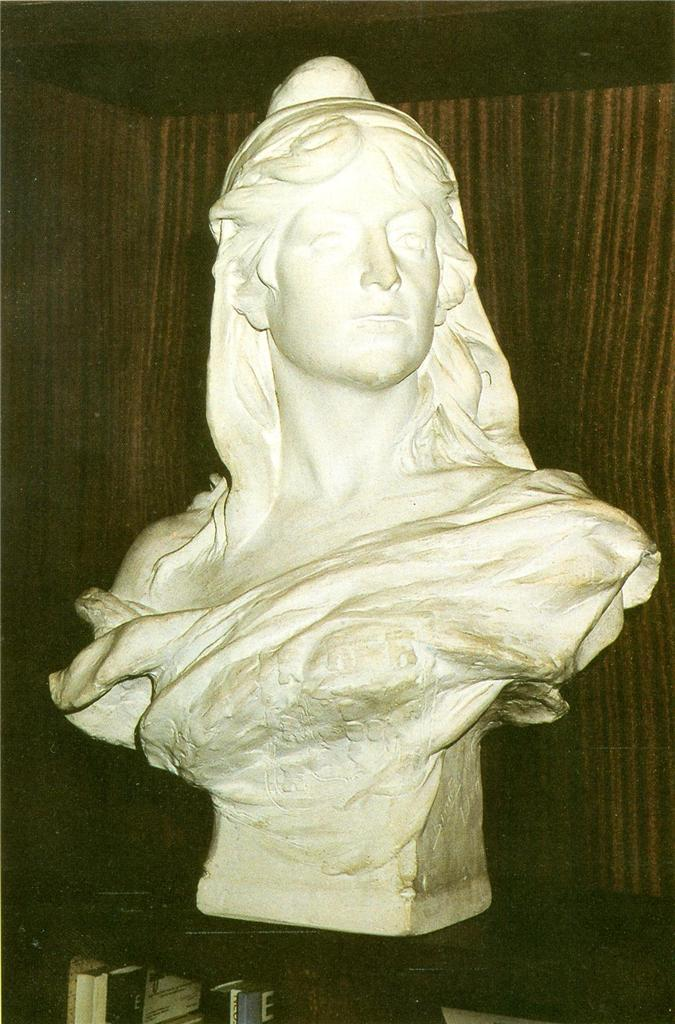What is the main subject in the center of the image? There is a sculpture in the center of the image. What can be seen in the background of the image? There is a wall in the background of the image. How does the bat stretch in the image? There is no bat present in the image, so it cannot be stretched or performing any actions. 